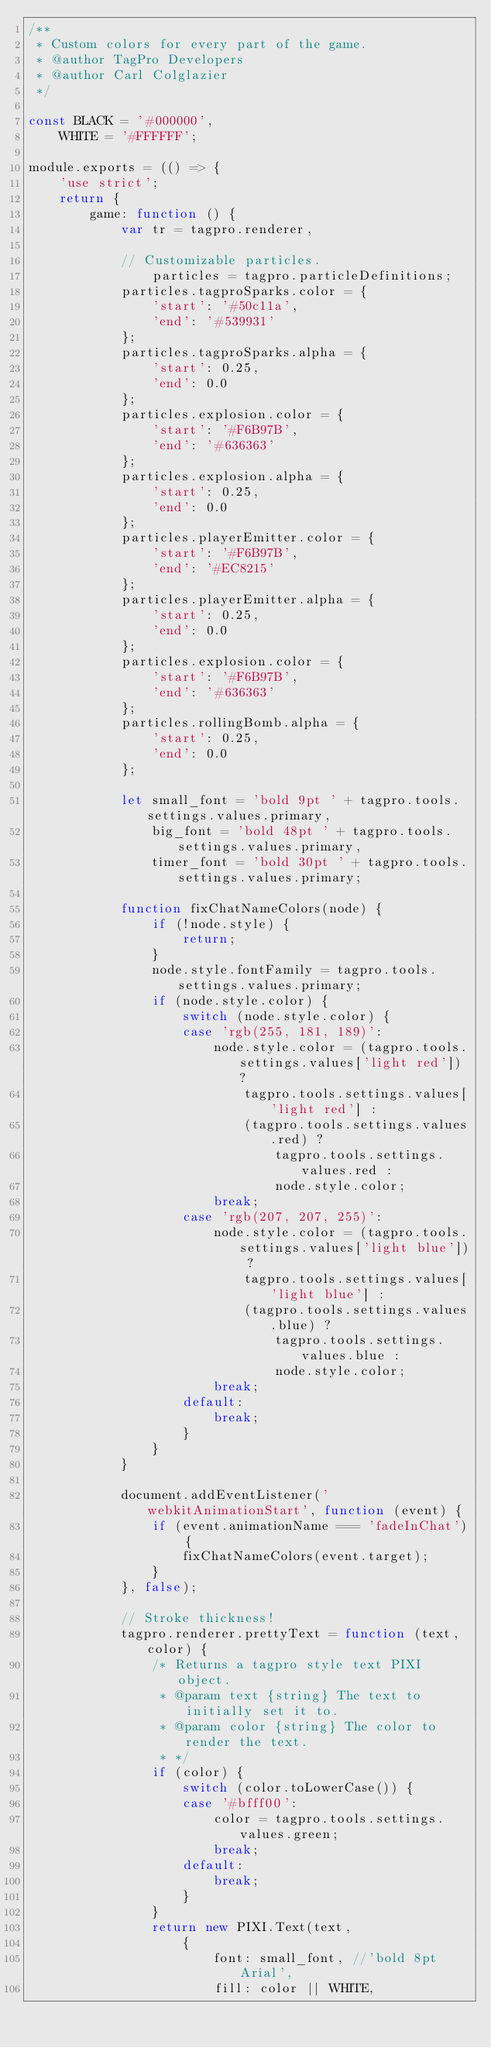<code> <loc_0><loc_0><loc_500><loc_500><_JavaScript_>/**
 * Custom colors for every part of the game.
 * @author TagPro Developers
 * @author Carl Colglazier
 */

const BLACK = '#000000',
    WHITE = '#FFFFFF';

module.exports = (() => {
    'use strict';
    return {
        game: function () {
            var tr = tagpro.renderer,

            // Customizable particles.
                particles = tagpro.particleDefinitions;
            particles.tagproSparks.color = {
                'start': '#50c11a',
                'end': '#539931'
            };
            particles.tagproSparks.alpha = {
                'start': 0.25,
                'end': 0.0
            };
            particles.explosion.color = {
                'start': '#F6B97B',
                'end': '#636363'
            };
            particles.explosion.alpha = {
                'start': 0.25,
                'end': 0.0
            };
            particles.playerEmitter.color = {
                'start': '#F6B97B',
                'end': '#EC8215'
            };
            particles.playerEmitter.alpha = {
                'start': 0.25,
                'end': 0.0
            };
            particles.explosion.color = {
                'start': '#F6B97B',
                'end': '#636363'
            };
            particles.rollingBomb.alpha = {
                'start': 0.25,
                'end': 0.0
            };

            let small_font = 'bold 9pt ' + tagpro.tools.settings.values.primary,
                big_font = 'bold 48pt ' + tagpro.tools.settings.values.primary,
                timer_font = 'bold 30pt ' + tagpro.tools.settings.values.primary;

            function fixChatNameColors(node) {
                if (!node.style) {
                    return;
                }
                node.style.fontFamily = tagpro.tools.settings.values.primary;
                if (node.style.color) {
                    switch (node.style.color) {
                    case 'rgb(255, 181, 189)':
                        node.style.color = (tagpro.tools.settings.values['light red']) ?
                            tagpro.tools.settings.values['light red'] :
                            (tagpro.tools.settings.values.red) ?
                                tagpro.tools.settings.values.red :
                                node.style.color;
                        break;
                    case 'rgb(207, 207, 255)':
                        node.style.color = (tagpro.tools.settings.values['light blue']) ?
                            tagpro.tools.settings.values['light blue'] :
                            (tagpro.tools.settings.values.blue) ?
                                tagpro.tools.settings.values.blue :
                                node.style.color;
                        break;
                    default:
                        break;
                    }
                }
            }

            document.addEventListener('webkitAnimationStart', function (event) {
                if (event.animationName === 'fadeInChat') {
                    fixChatNameColors(event.target);
                }
            }, false);

            // Stroke thickness!
            tagpro.renderer.prettyText = function (text, color) {
                /* Returns a tagpro style text PIXI object.
                 * @param text {string} The text to initially set it to.
                 * @param color {string} The color to render the text.
                 * */
                if (color) {
                    switch (color.toLowerCase()) {
                    case '#bfff00':
                        color = tagpro.tools.settings.values.green;
                        break;
                    default:
                        break;
                    }
                }
                return new PIXI.Text(text,
                    {
                        font: small_font, //'bold 8pt Arial',
                        fill: color || WHITE,</code> 